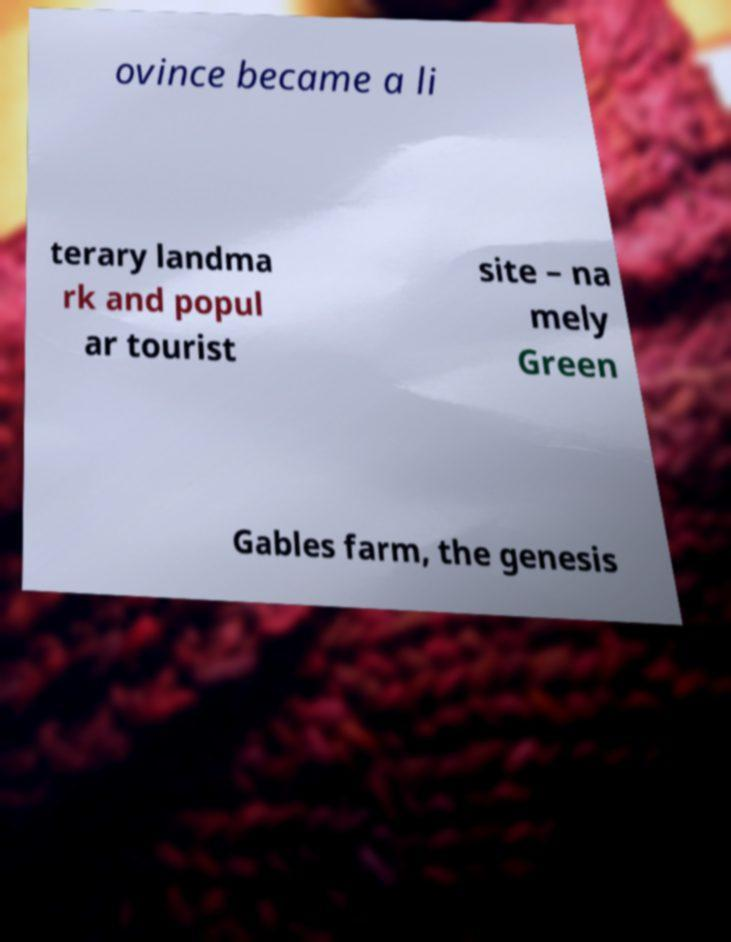There's text embedded in this image that I need extracted. Can you transcribe it verbatim? ovince became a li terary landma rk and popul ar tourist site – na mely Green Gables farm, the genesis 